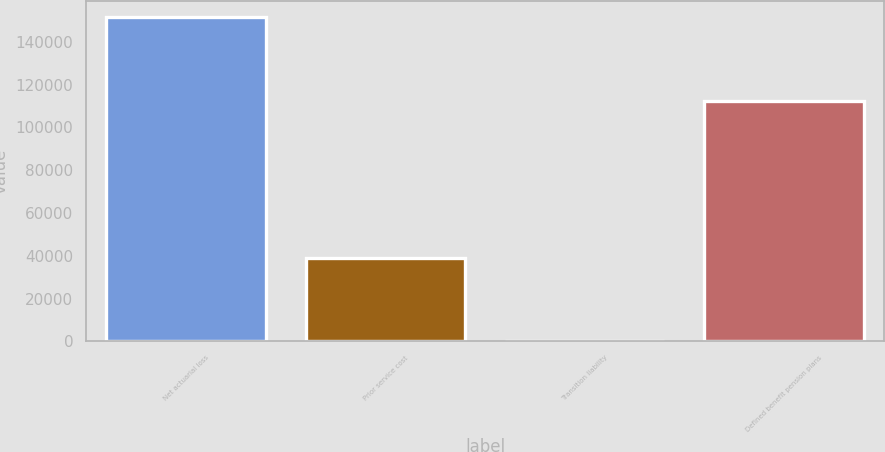Convert chart to OTSL. <chart><loc_0><loc_0><loc_500><loc_500><bar_chart><fcel>Net actuarial loss<fcel>Prior service cost<fcel>Transition liability<fcel>Defined benefit pension plans<nl><fcel>151564<fcel>39093<fcel>3<fcel>112468<nl></chart> 